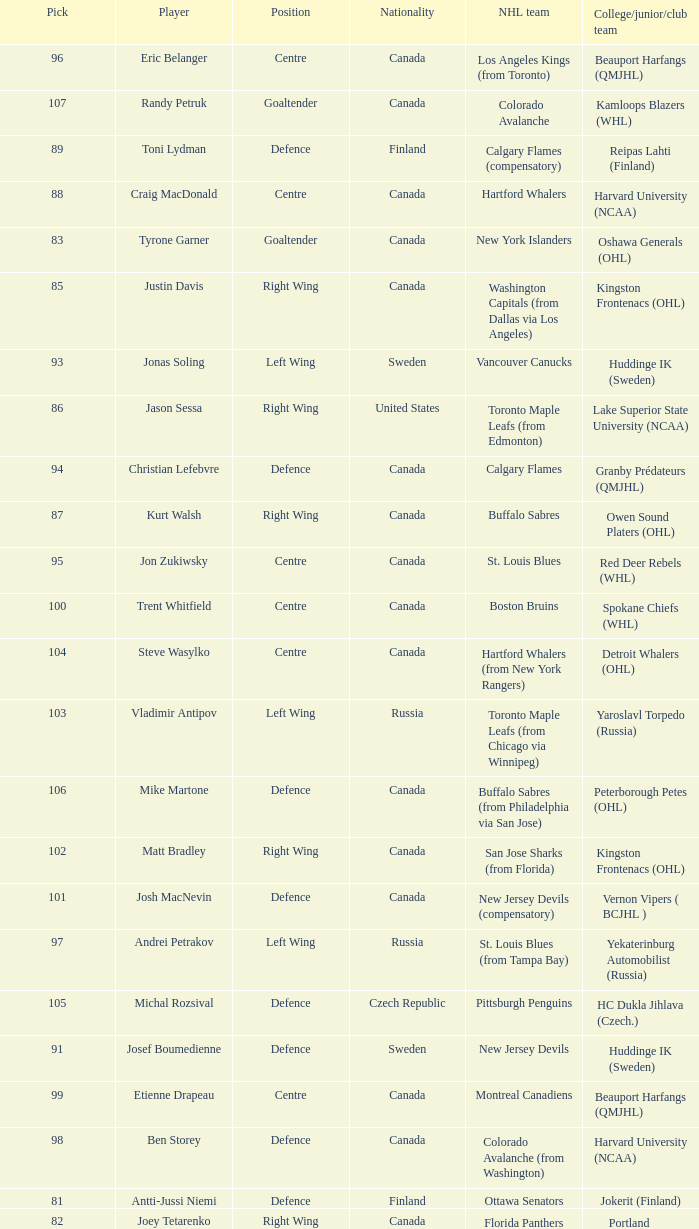What position does that draft pick play from Lake Superior State University (NCAA)? Right Wing. 